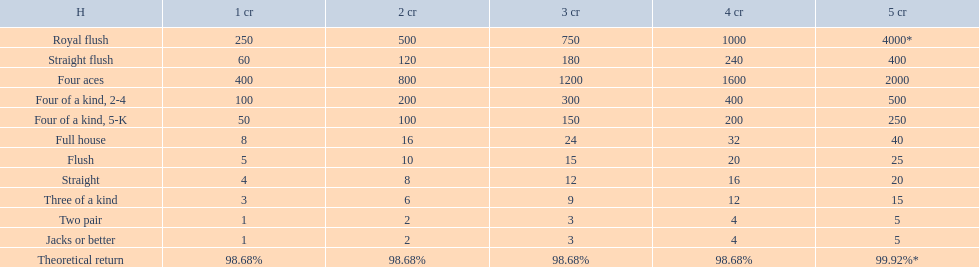Parse the full table. {'header': ['H', '1 cr', '2 cr', '3 cr', '4 cr', '5 cr'], 'rows': [['Royal flush', '250', '500', '750', '1000', '4000*'], ['Straight flush', '60', '120', '180', '240', '400'], ['Four aces', '400', '800', '1200', '1600', '2000'], ['Four of a kind, 2-4', '100', '200', '300', '400', '500'], ['Four of a kind, 5-K', '50', '100', '150', '200', '250'], ['Full house', '8', '16', '24', '32', '40'], ['Flush', '5', '10', '15', '20', '25'], ['Straight', '4', '8', '12', '16', '20'], ['Three of a kind', '3', '6', '9', '12', '15'], ['Two pair', '1', '2', '3', '4', '5'], ['Jacks or better', '1', '2', '3', '4', '5'], ['Theoretical return', '98.68%', '98.68%', '98.68%', '98.68%', '99.92%*']]} What are the top 5 best types of hand for winning? Royal flush, Straight flush, Four aces, Four of a kind, 2-4, Four of a kind, 5-K. Between those 5, which of those hands are four of a kind? Four of a kind, 2-4, Four of a kind, 5-K. Of those 2 hands, which is the best kind of four of a kind for winning? Four of a kind, 2-4. 